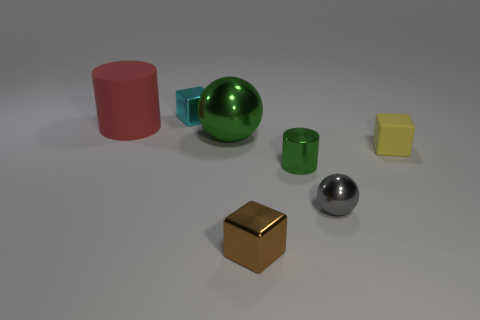What is the size of the cylinder on the right side of the cylinder that is left of the cyan metal cube behind the large green metallic sphere?
Your answer should be compact. Small. Are there the same number of gray objects that are behind the tiny gray sphere and small yellow blocks?
Make the answer very short. No. Are there any other things that are the same shape as the tiny cyan metal thing?
Your answer should be compact. Yes. There is a small cyan shiny object; does it have the same shape as the object to the right of the small gray thing?
Make the answer very short. Yes. There is another matte thing that is the same shape as the tiny cyan thing; what is its size?
Provide a short and direct response. Small. What number of other objects are there of the same material as the yellow cube?
Make the answer very short. 1. What is the material of the tiny gray object?
Give a very brief answer. Metal. There is a tiny object that is to the left of the green metallic ball; does it have the same color as the shiny ball in front of the tiny yellow matte cube?
Your answer should be compact. No. Is the number of green metal balls in front of the tiny yellow rubber block greater than the number of red cylinders?
Your answer should be very brief. No. How many other things are there of the same color as the shiny cylinder?
Make the answer very short. 1. 